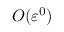Convert formula to latex. <formula><loc_0><loc_0><loc_500><loc_500>O ( \varepsilon ^ { 0 } )</formula> 